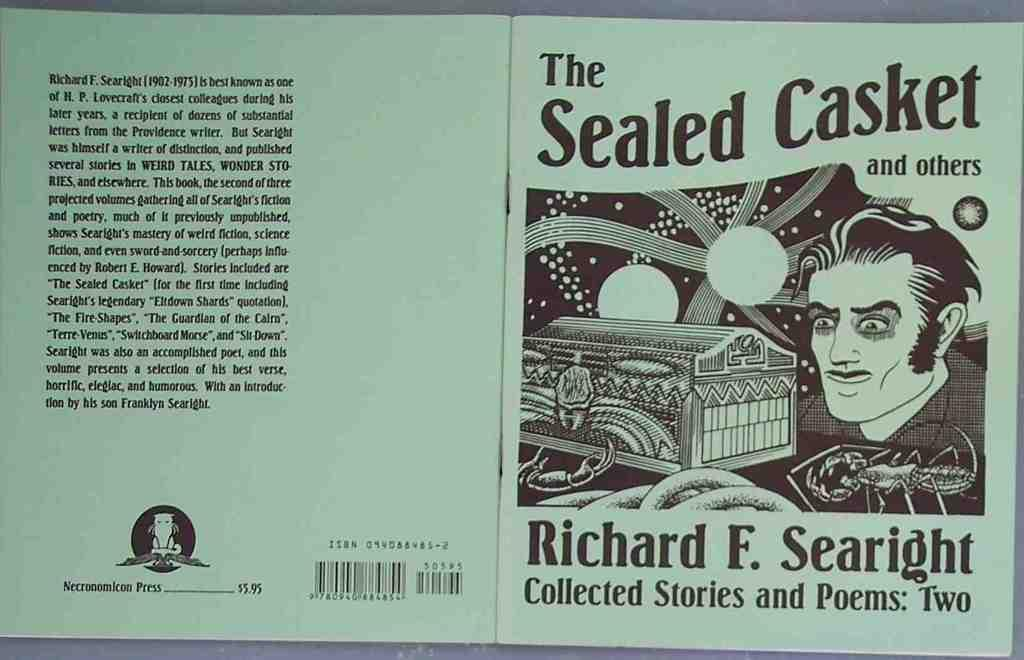<image>
Share a concise interpretation of the image provided. Small book with poems and stories that says The Sealed Casket and Others. 